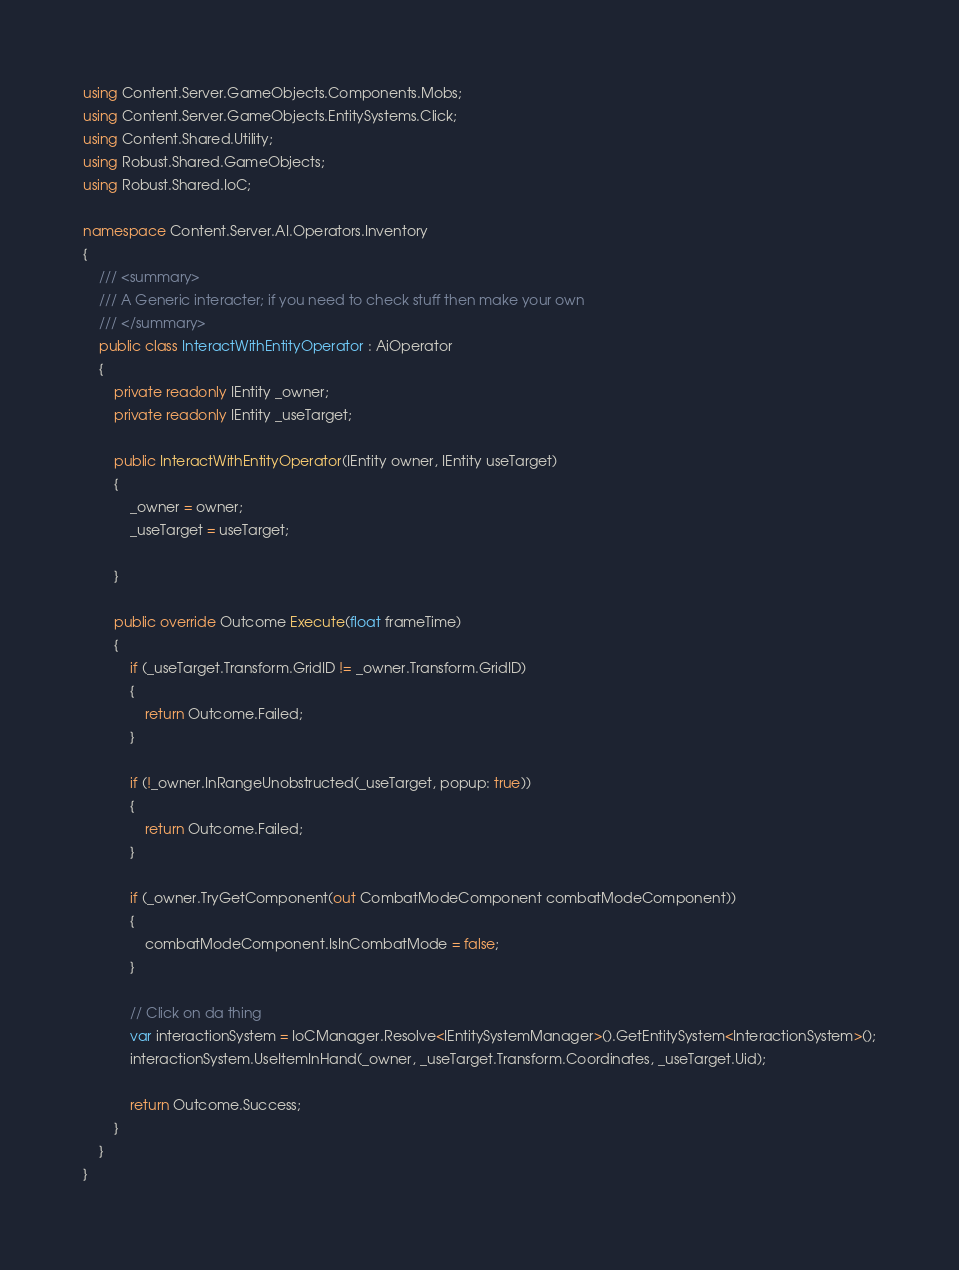<code> <loc_0><loc_0><loc_500><loc_500><_C#_>using Content.Server.GameObjects.Components.Mobs;
using Content.Server.GameObjects.EntitySystems.Click;
using Content.Shared.Utility;
using Robust.Shared.GameObjects;
using Robust.Shared.IoC;

namespace Content.Server.AI.Operators.Inventory
{
    /// <summary>
    /// A Generic interacter; if you need to check stuff then make your own
    /// </summary>
    public class InteractWithEntityOperator : AiOperator
    {
        private readonly IEntity _owner;
        private readonly IEntity _useTarget;

        public InteractWithEntityOperator(IEntity owner, IEntity useTarget)
        {
            _owner = owner;
            _useTarget = useTarget;

        }

        public override Outcome Execute(float frameTime)
        {
            if (_useTarget.Transform.GridID != _owner.Transform.GridID)
            {
                return Outcome.Failed;
            }

            if (!_owner.InRangeUnobstructed(_useTarget, popup: true))
            {
                return Outcome.Failed;
            }

            if (_owner.TryGetComponent(out CombatModeComponent combatModeComponent))
            {
                combatModeComponent.IsInCombatMode = false;
            }

            // Click on da thing
            var interactionSystem = IoCManager.Resolve<IEntitySystemManager>().GetEntitySystem<InteractionSystem>();
            interactionSystem.UseItemInHand(_owner, _useTarget.Transform.Coordinates, _useTarget.Uid);

            return Outcome.Success;
        }
    }
}
</code> 